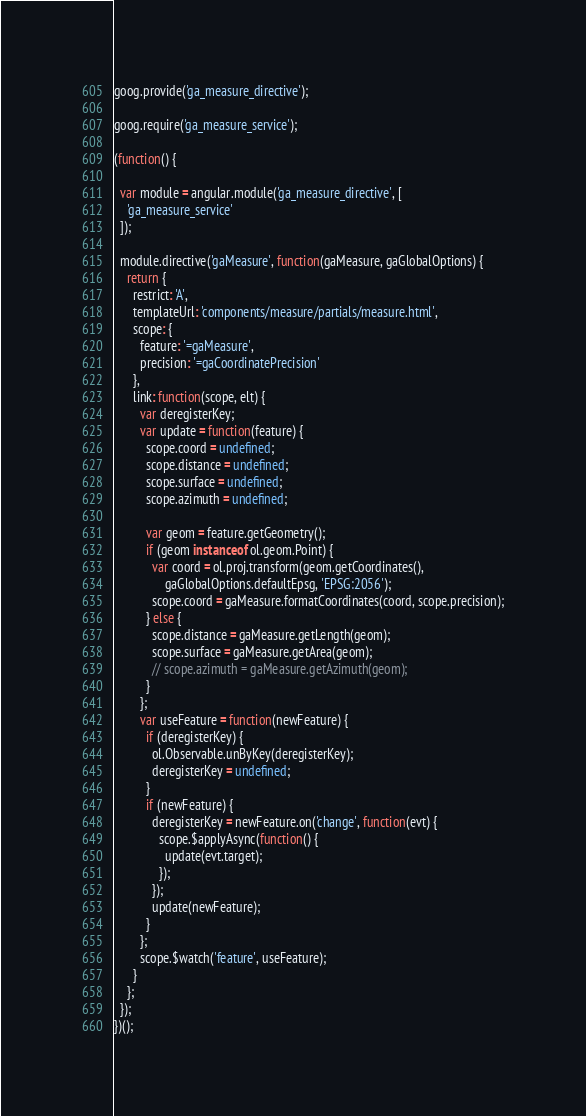Convert code to text. <code><loc_0><loc_0><loc_500><loc_500><_JavaScript_>goog.provide('ga_measure_directive');

goog.require('ga_measure_service');

(function() {

  var module = angular.module('ga_measure_directive', [
    'ga_measure_service'
  ]);

  module.directive('gaMeasure', function(gaMeasure, gaGlobalOptions) {
    return {
      restrict: 'A',
      templateUrl: 'components/measure/partials/measure.html',
      scope: {
        feature: '=gaMeasure',
        precision: '=gaCoordinatePrecision'
      },
      link: function(scope, elt) {
        var deregisterKey;
        var update = function(feature) {
          scope.coord = undefined;
          scope.distance = undefined;
          scope.surface = undefined;
          scope.azimuth = undefined;

          var geom = feature.getGeometry();
          if (geom instanceof ol.geom.Point) {
            var coord = ol.proj.transform(geom.getCoordinates(),
                gaGlobalOptions.defaultEpsg, 'EPSG:2056');
            scope.coord = gaMeasure.formatCoordinates(coord, scope.precision);
          } else {
            scope.distance = gaMeasure.getLength(geom);
            scope.surface = gaMeasure.getArea(geom);
            // scope.azimuth = gaMeasure.getAzimuth(geom);
          }
        };
        var useFeature = function(newFeature) {
          if (deregisterKey) {
            ol.Observable.unByKey(deregisterKey);
            deregisterKey = undefined;
          }
          if (newFeature) {
            deregisterKey = newFeature.on('change', function(evt) {
              scope.$applyAsync(function() {
                update(evt.target);
              });
            });
            update(newFeature);
          }
        };
        scope.$watch('feature', useFeature);
      }
    };
  });
})();
</code> 